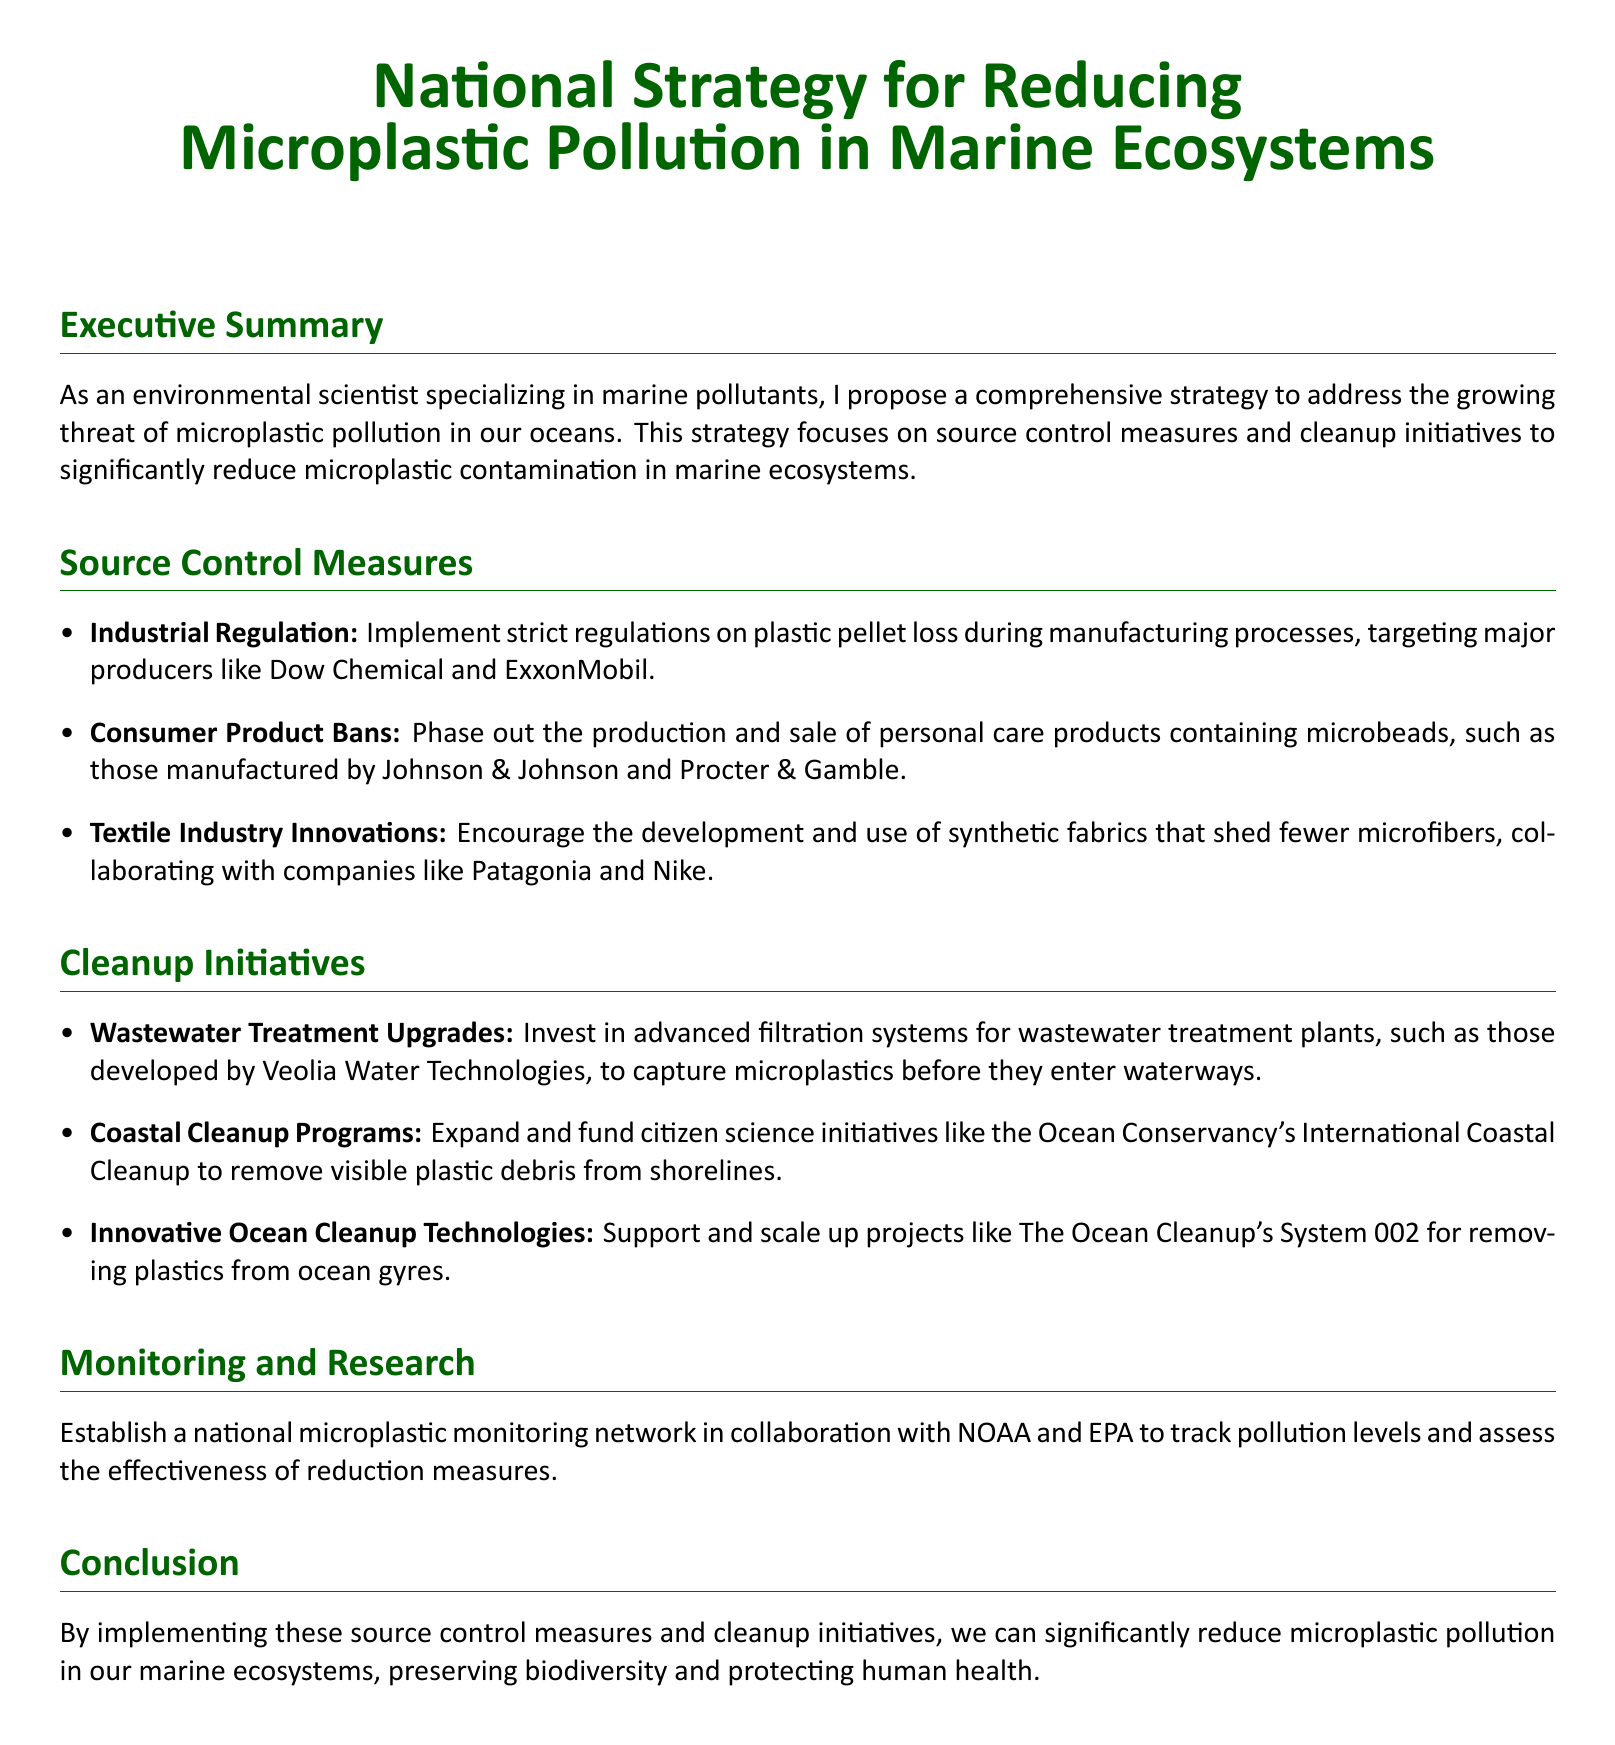What is the focus of the national strategy? The focus of the national strategy is on source control measures and cleanup initiatives to reduce microplastic contamination.
Answer: source control measures and cleanup initiatives Which companies are targeted for industrial regulation? The companies targeted for industrial regulation on plastic pellet loss include major producers like Dow Chemical and ExxonMobil.
Answer: Dow Chemical and ExxonMobil What personal care products are banned? The document mentions a phase-out of production and sale of personal care products containing microbeads.
Answer: personal care products containing microbeads What technology is suggested for wastewater treatment upgrades? The suggested technology for wastewater treatment upgrades includes advanced filtration systems developed by Veolia Water Technologies.
Answer: advanced filtration systems What citizen science initiative is mentioned in the cleanup programs? The Ocean Conservancy's International Coastal Cleanup is mentioned as a citizen science initiative to remove visible plastic debris.
Answer: International Coastal Cleanup Which organizations are involved in the national microplastic monitoring network? NOAA and EPA are involved in establishing the national microplastic monitoring network.
Answer: NOAA and EPA What is the proposed outcome of implementing the suggested measures? The proposed outcome is to significantly reduce microplastic pollution in marine ecosystems, preserving biodiversity and protecting human health.
Answer: significantly reduce microplastic pollution What type of monitoring is proposed in the document? A national microplastic monitoring network is proposed in collaboration with NOAA and EPA.
Answer: national microplastic monitoring network 